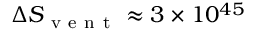<formula> <loc_0><loc_0><loc_500><loc_500>\Delta S _ { v e n t } \approx 3 \times 1 0 ^ { 4 5 }</formula> 